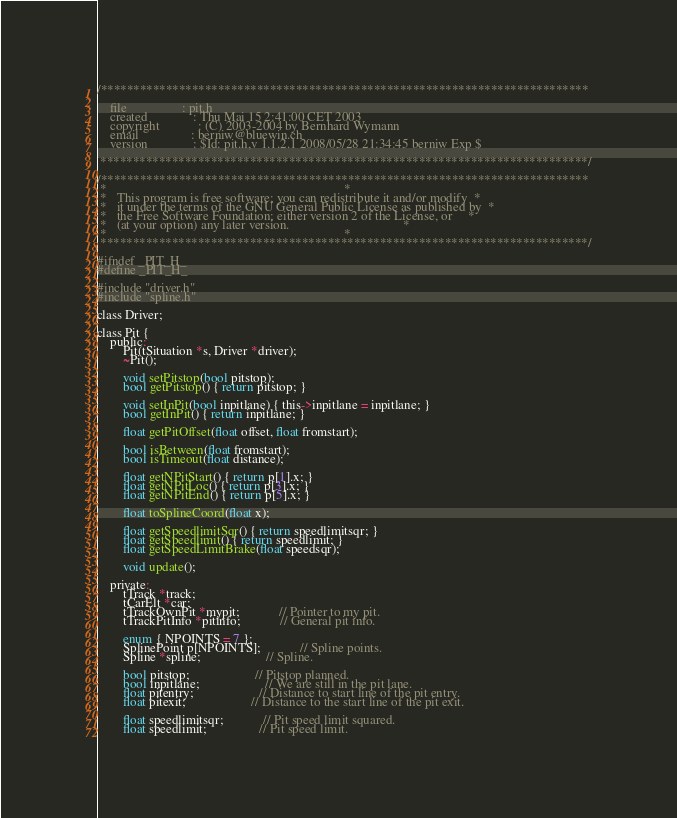Convert code to text. <code><loc_0><loc_0><loc_500><loc_500><_C_>/***************************************************************************

    file                 : pit.h
    created              : Thu Mai 15 2:41:00 CET 2003
    copyright            : (C) 2003-2004 by Bernhard Wymann
    email                : berniw@bluewin.ch
    version              : $Id: pit.h,v 1.1.2.1 2008/05/28 21:34:45 berniw Exp $

 ***************************************************************************/

/***************************************************************************
 *                                                                         *
 *   This program is free software; you can redistribute it and/or modify  *
 *   it under the terms of the GNU General Public License as published by  *
 *   the Free Software Foundation; either version 2 of the License, or     *
 *   (at your option) any later version.                                   *
 *                                                                         *
 ***************************************************************************/

#ifndef _PIT_H_
#define _PIT_H_

#include "driver.h"
#include "spline.h"

class Driver;

class Pit {
	public:
		Pit(tSituation *s, Driver *driver);
		~Pit();

		void setPitstop(bool pitstop);
		bool getPitstop() { return pitstop; }

		void setInPit(bool inpitlane) { this->inpitlane = inpitlane; }
		bool getInPit() { return inpitlane; }

		float getPitOffset(float offset, float fromstart);

		bool isBetween(float fromstart);
		bool isTimeout(float distance);

		float getNPitStart() { return p[1].x; }
		float getNPitLoc() { return p[3].x; }
		float getNPitEnd() { return p[5].x; }

		float toSplineCoord(float x);

		float getSpeedlimitSqr() { return speedlimitsqr; }
		float getSpeedlimit() { return speedlimit; }
		float getSpeedLimitBrake(float speedsqr);

		void update();

	private:
		tTrack *track;
		tCarElt *car;
		tTrackOwnPit *mypit;			// Pointer to my pit.
		tTrackPitInfo *pitinfo;			// General pit info.

		enum { NPOINTS = 7 };
		SplinePoint p[NPOINTS];			// Spline points.
		Spline *spline;					// Spline.

		bool pitstop;					// Pitstop planned.
		bool inpitlane;					// We are still in the pit lane.
		float pitentry;					// Distance to start line of the pit entry.
		float pitexit;					// Distance to the start line of the pit exit.

		float speedlimitsqr;			// Pit speed limit squared.
		float speedlimit;				// Pit speed limit.</code> 